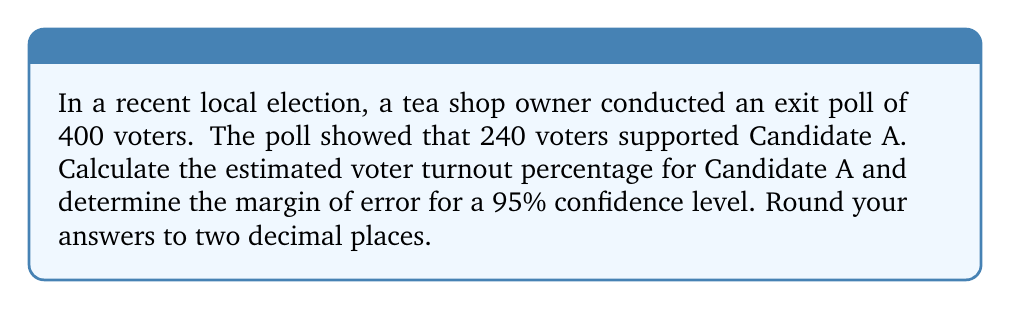What is the answer to this math problem? Step 1: Calculate the estimated voter turnout percentage for Candidate A.
Percentage = (Number of supporters / Total surveyed) × 100
Percentage = (240 / 400) × 100 = 60%

Step 2: Calculate the margin of error using the formula:
$$ \text{Margin of Error} = z \times \sqrt{\frac{p(1-p)}{n}} $$
Where:
z = z-score (1.96 for 95% confidence level)
p = sample proportion (0.60)
n = sample size (400)

$$ \text{Margin of Error} = 1.96 \times \sqrt{\frac{0.60(1-0.60)}{400}} $$
$$ = 1.96 \times \sqrt{\frac{0.24}{400}} $$
$$ = 1.96 \times \sqrt{0.0006} $$
$$ = 1.96 \times 0.0245 $$
$$ = 0.04802 $$

Step 3: Round the margin of error to two decimal places.
Margin of Error = 0.05 or 5%

Therefore, we can say that the estimated voter turnout for Candidate A is 60% ± 5% with a 95% confidence level.
Answer: 60% ± 5% 